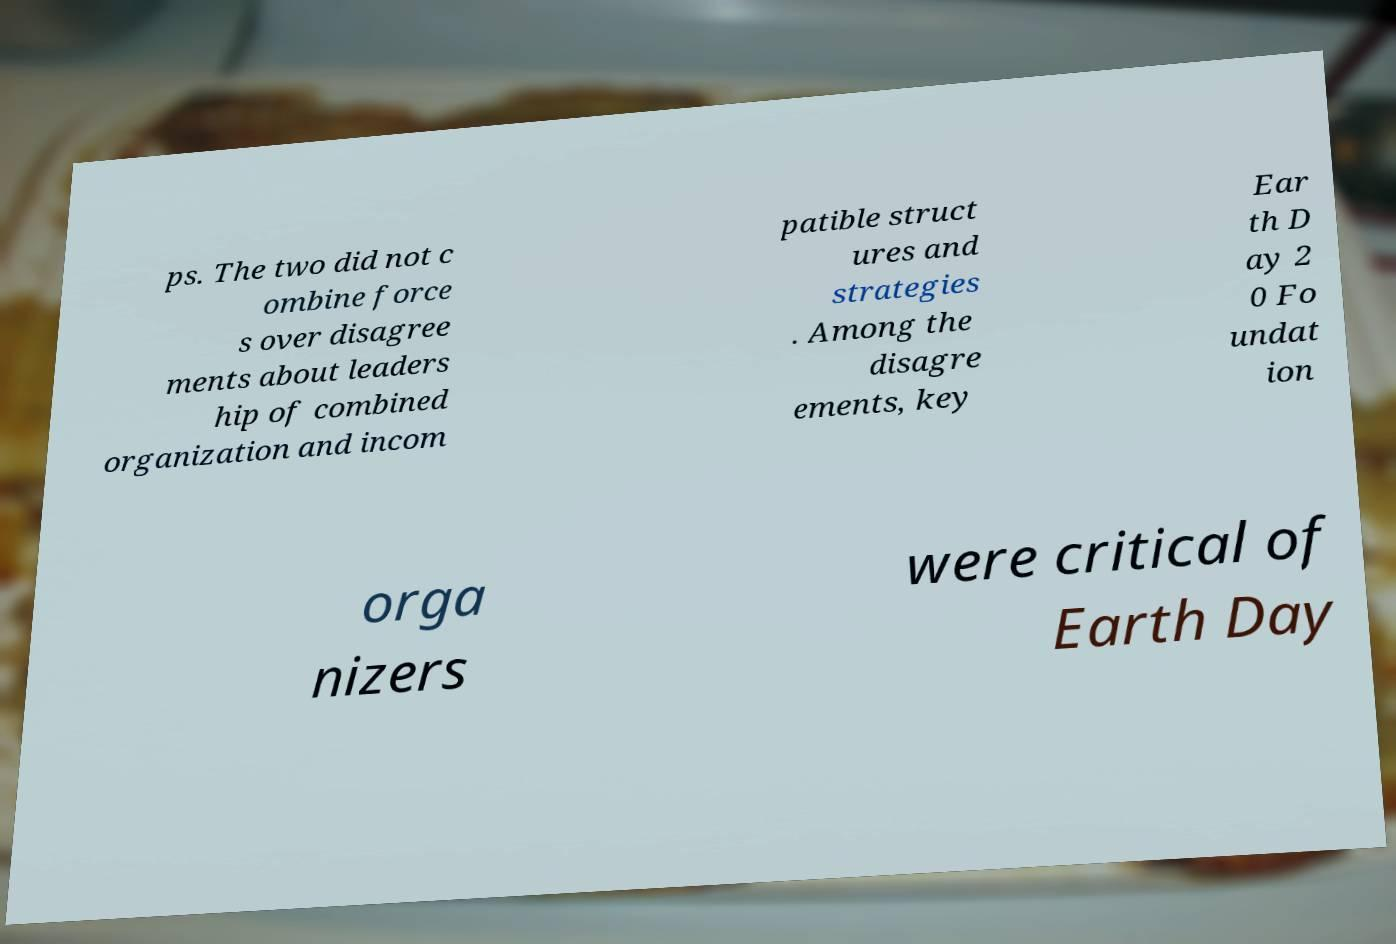Please identify and transcribe the text found in this image. ps. The two did not c ombine force s over disagree ments about leaders hip of combined organization and incom patible struct ures and strategies . Among the disagre ements, key Ear th D ay 2 0 Fo undat ion orga nizers were critical of Earth Day 